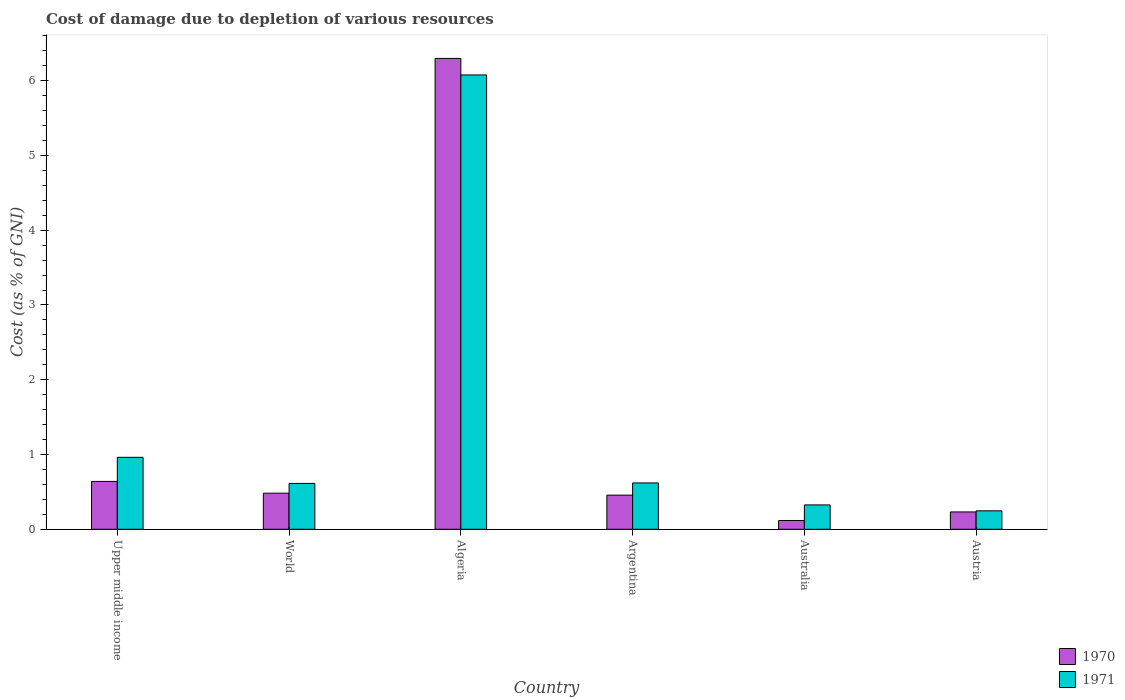How many groups of bars are there?
Your response must be concise. 6. How many bars are there on the 1st tick from the left?
Give a very brief answer. 2. What is the label of the 6th group of bars from the left?
Your answer should be compact. Austria. In how many cases, is the number of bars for a given country not equal to the number of legend labels?
Provide a short and direct response. 0. What is the cost of damage caused due to the depletion of various resources in 1971 in World?
Give a very brief answer. 0.61. Across all countries, what is the maximum cost of damage caused due to the depletion of various resources in 1971?
Make the answer very short. 6.08. Across all countries, what is the minimum cost of damage caused due to the depletion of various resources in 1970?
Provide a short and direct response. 0.12. In which country was the cost of damage caused due to the depletion of various resources in 1970 maximum?
Ensure brevity in your answer.  Algeria. In which country was the cost of damage caused due to the depletion of various resources in 1971 minimum?
Give a very brief answer. Austria. What is the total cost of damage caused due to the depletion of various resources in 1971 in the graph?
Ensure brevity in your answer.  8.85. What is the difference between the cost of damage caused due to the depletion of various resources in 1971 in Australia and that in World?
Give a very brief answer. -0.29. What is the difference between the cost of damage caused due to the depletion of various resources in 1970 in Australia and the cost of damage caused due to the depletion of various resources in 1971 in Austria?
Give a very brief answer. -0.13. What is the average cost of damage caused due to the depletion of various resources in 1971 per country?
Offer a very short reply. 1.47. What is the difference between the cost of damage caused due to the depletion of various resources of/in 1970 and cost of damage caused due to the depletion of various resources of/in 1971 in Argentina?
Your answer should be compact. -0.16. In how many countries, is the cost of damage caused due to the depletion of various resources in 1970 greater than 3.4 %?
Your answer should be compact. 1. What is the ratio of the cost of damage caused due to the depletion of various resources in 1970 in Upper middle income to that in World?
Provide a succinct answer. 1.33. Is the cost of damage caused due to the depletion of various resources in 1971 in Austria less than that in World?
Your response must be concise. Yes. Is the difference between the cost of damage caused due to the depletion of various resources in 1970 in Australia and Austria greater than the difference between the cost of damage caused due to the depletion of various resources in 1971 in Australia and Austria?
Make the answer very short. No. What is the difference between the highest and the second highest cost of damage caused due to the depletion of various resources in 1970?
Provide a short and direct response. 0.16. What is the difference between the highest and the lowest cost of damage caused due to the depletion of various resources in 1970?
Provide a succinct answer. 6.18. In how many countries, is the cost of damage caused due to the depletion of various resources in 1970 greater than the average cost of damage caused due to the depletion of various resources in 1970 taken over all countries?
Keep it short and to the point. 1. Is the sum of the cost of damage caused due to the depletion of various resources in 1970 in Algeria and World greater than the maximum cost of damage caused due to the depletion of various resources in 1971 across all countries?
Your answer should be very brief. Yes. How many bars are there?
Your response must be concise. 12. Are all the bars in the graph horizontal?
Make the answer very short. No. What is the difference between two consecutive major ticks on the Y-axis?
Make the answer very short. 1. Are the values on the major ticks of Y-axis written in scientific E-notation?
Keep it short and to the point. No. Does the graph contain grids?
Make the answer very short. No. Where does the legend appear in the graph?
Make the answer very short. Bottom right. How are the legend labels stacked?
Your answer should be very brief. Vertical. What is the title of the graph?
Offer a terse response. Cost of damage due to depletion of various resources. What is the label or title of the Y-axis?
Provide a short and direct response. Cost (as % of GNI). What is the Cost (as % of GNI) of 1970 in Upper middle income?
Provide a short and direct response. 0.64. What is the Cost (as % of GNI) of 1971 in Upper middle income?
Your answer should be compact. 0.96. What is the Cost (as % of GNI) of 1970 in World?
Your answer should be very brief. 0.48. What is the Cost (as % of GNI) in 1971 in World?
Provide a succinct answer. 0.61. What is the Cost (as % of GNI) of 1970 in Algeria?
Your answer should be compact. 6.3. What is the Cost (as % of GNI) of 1971 in Algeria?
Offer a very short reply. 6.08. What is the Cost (as % of GNI) in 1970 in Argentina?
Ensure brevity in your answer.  0.46. What is the Cost (as % of GNI) of 1971 in Argentina?
Keep it short and to the point. 0.62. What is the Cost (as % of GNI) of 1970 in Australia?
Your answer should be very brief. 0.12. What is the Cost (as % of GNI) of 1971 in Australia?
Provide a succinct answer. 0.33. What is the Cost (as % of GNI) in 1970 in Austria?
Your response must be concise. 0.23. What is the Cost (as % of GNI) in 1971 in Austria?
Make the answer very short. 0.25. Across all countries, what is the maximum Cost (as % of GNI) in 1970?
Provide a succinct answer. 6.3. Across all countries, what is the maximum Cost (as % of GNI) of 1971?
Provide a short and direct response. 6.08. Across all countries, what is the minimum Cost (as % of GNI) of 1970?
Provide a succinct answer. 0.12. Across all countries, what is the minimum Cost (as % of GNI) of 1971?
Provide a succinct answer. 0.25. What is the total Cost (as % of GNI) in 1970 in the graph?
Keep it short and to the point. 8.23. What is the total Cost (as % of GNI) in 1971 in the graph?
Keep it short and to the point. 8.85. What is the difference between the Cost (as % of GNI) in 1970 in Upper middle income and that in World?
Make the answer very short. 0.16. What is the difference between the Cost (as % of GNI) in 1971 in Upper middle income and that in World?
Make the answer very short. 0.35. What is the difference between the Cost (as % of GNI) in 1970 in Upper middle income and that in Algeria?
Give a very brief answer. -5.66. What is the difference between the Cost (as % of GNI) of 1971 in Upper middle income and that in Algeria?
Provide a succinct answer. -5.11. What is the difference between the Cost (as % of GNI) of 1970 in Upper middle income and that in Argentina?
Keep it short and to the point. 0.18. What is the difference between the Cost (as % of GNI) in 1971 in Upper middle income and that in Argentina?
Provide a short and direct response. 0.34. What is the difference between the Cost (as % of GNI) of 1970 in Upper middle income and that in Australia?
Make the answer very short. 0.52. What is the difference between the Cost (as % of GNI) of 1971 in Upper middle income and that in Australia?
Provide a succinct answer. 0.64. What is the difference between the Cost (as % of GNI) in 1970 in Upper middle income and that in Austria?
Offer a very short reply. 0.41. What is the difference between the Cost (as % of GNI) in 1971 in Upper middle income and that in Austria?
Provide a succinct answer. 0.72. What is the difference between the Cost (as % of GNI) in 1970 in World and that in Algeria?
Offer a very short reply. -5.82. What is the difference between the Cost (as % of GNI) in 1971 in World and that in Algeria?
Your answer should be very brief. -5.46. What is the difference between the Cost (as % of GNI) in 1970 in World and that in Argentina?
Your answer should be very brief. 0.03. What is the difference between the Cost (as % of GNI) in 1971 in World and that in Argentina?
Offer a very short reply. -0.01. What is the difference between the Cost (as % of GNI) in 1970 in World and that in Australia?
Offer a terse response. 0.37. What is the difference between the Cost (as % of GNI) in 1971 in World and that in Australia?
Make the answer very short. 0.29. What is the difference between the Cost (as % of GNI) in 1970 in World and that in Austria?
Your answer should be very brief. 0.25. What is the difference between the Cost (as % of GNI) in 1971 in World and that in Austria?
Make the answer very short. 0.37. What is the difference between the Cost (as % of GNI) of 1970 in Algeria and that in Argentina?
Your answer should be very brief. 5.84. What is the difference between the Cost (as % of GNI) of 1971 in Algeria and that in Argentina?
Offer a terse response. 5.46. What is the difference between the Cost (as % of GNI) of 1970 in Algeria and that in Australia?
Your response must be concise. 6.18. What is the difference between the Cost (as % of GNI) of 1971 in Algeria and that in Australia?
Provide a succinct answer. 5.75. What is the difference between the Cost (as % of GNI) of 1970 in Algeria and that in Austria?
Offer a terse response. 6.07. What is the difference between the Cost (as % of GNI) of 1971 in Algeria and that in Austria?
Offer a terse response. 5.83. What is the difference between the Cost (as % of GNI) of 1970 in Argentina and that in Australia?
Ensure brevity in your answer.  0.34. What is the difference between the Cost (as % of GNI) of 1971 in Argentina and that in Australia?
Your response must be concise. 0.29. What is the difference between the Cost (as % of GNI) in 1970 in Argentina and that in Austria?
Your answer should be very brief. 0.22. What is the difference between the Cost (as % of GNI) of 1971 in Argentina and that in Austria?
Keep it short and to the point. 0.37. What is the difference between the Cost (as % of GNI) of 1970 in Australia and that in Austria?
Ensure brevity in your answer.  -0.11. What is the difference between the Cost (as % of GNI) in 1971 in Australia and that in Austria?
Provide a succinct answer. 0.08. What is the difference between the Cost (as % of GNI) of 1970 in Upper middle income and the Cost (as % of GNI) of 1971 in World?
Make the answer very short. 0.03. What is the difference between the Cost (as % of GNI) in 1970 in Upper middle income and the Cost (as % of GNI) in 1971 in Algeria?
Provide a short and direct response. -5.44. What is the difference between the Cost (as % of GNI) in 1970 in Upper middle income and the Cost (as % of GNI) in 1971 in Argentina?
Provide a short and direct response. 0.02. What is the difference between the Cost (as % of GNI) in 1970 in Upper middle income and the Cost (as % of GNI) in 1971 in Australia?
Provide a succinct answer. 0.31. What is the difference between the Cost (as % of GNI) in 1970 in Upper middle income and the Cost (as % of GNI) in 1971 in Austria?
Your response must be concise. 0.39. What is the difference between the Cost (as % of GNI) of 1970 in World and the Cost (as % of GNI) of 1971 in Algeria?
Provide a succinct answer. -5.59. What is the difference between the Cost (as % of GNI) in 1970 in World and the Cost (as % of GNI) in 1971 in Argentina?
Keep it short and to the point. -0.14. What is the difference between the Cost (as % of GNI) in 1970 in World and the Cost (as % of GNI) in 1971 in Australia?
Give a very brief answer. 0.16. What is the difference between the Cost (as % of GNI) of 1970 in World and the Cost (as % of GNI) of 1971 in Austria?
Provide a succinct answer. 0.24. What is the difference between the Cost (as % of GNI) of 1970 in Algeria and the Cost (as % of GNI) of 1971 in Argentina?
Give a very brief answer. 5.68. What is the difference between the Cost (as % of GNI) of 1970 in Algeria and the Cost (as % of GNI) of 1971 in Australia?
Provide a succinct answer. 5.97. What is the difference between the Cost (as % of GNI) in 1970 in Algeria and the Cost (as % of GNI) in 1971 in Austria?
Give a very brief answer. 6.05. What is the difference between the Cost (as % of GNI) in 1970 in Argentina and the Cost (as % of GNI) in 1971 in Australia?
Offer a terse response. 0.13. What is the difference between the Cost (as % of GNI) in 1970 in Argentina and the Cost (as % of GNI) in 1971 in Austria?
Ensure brevity in your answer.  0.21. What is the difference between the Cost (as % of GNI) of 1970 in Australia and the Cost (as % of GNI) of 1971 in Austria?
Offer a terse response. -0.13. What is the average Cost (as % of GNI) in 1970 per country?
Ensure brevity in your answer.  1.37. What is the average Cost (as % of GNI) of 1971 per country?
Give a very brief answer. 1.47. What is the difference between the Cost (as % of GNI) in 1970 and Cost (as % of GNI) in 1971 in Upper middle income?
Offer a terse response. -0.32. What is the difference between the Cost (as % of GNI) in 1970 and Cost (as % of GNI) in 1971 in World?
Your response must be concise. -0.13. What is the difference between the Cost (as % of GNI) of 1970 and Cost (as % of GNI) of 1971 in Algeria?
Offer a very short reply. 0.22. What is the difference between the Cost (as % of GNI) in 1970 and Cost (as % of GNI) in 1971 in Argentina?
Your answer should be compact. -0.16. What is the difference between the Cost (as % of GNI) in 1970 and Cost (as % of GNI) in 1971 in Australia?
Your response must be concise. -0.21. What is the difference between the Cost (as % of GNI) in 1970 and Cost (as % of GNI) in 1971 in Austria?
Make the answer very short. -0.01. What is the ratio of the Cost (as % of GNI) of 1970 in Upper middle income to that in World?
Your response must be concise. 1.33. What is the ratio of the Cost (as % of GNI) of 1971 in Upper middle income to that in World?
Your answer should be compact. 1.57. What is the ratio of the Cost (as % of GNI) in 1970 in Upper middle income to that in Algeria?
Offer a terse response. 0.1. What is the ratio of the Cost (as % of GNI) in 1971 in Upper middle income to that in Algeria?
Keep it short and to the point. 0.16. What is the ratio of the Cost (as % of GNI) of 1970 in Upper middle income to that in Argentina?
Make the answer very short. 1.4. What is the ratio of the Cost (as % of GNI) in 1971 in Upper middle income to that in Argentina?
Ensure brevity in your answer.  1.55. What is the ratio of the Cost (as % of GNI) of 1970 in Upper middle income to that in Australia?
Offer a terse response. 5.45. What is the ratio of the Cost (as % of GNI) of 1971 in Upper middle income to that in Australia?
Offer a terse response. 2.95. What is the ratio of the Cost (as % of GNI) of 1970 in Upper middle income to that in Austria?
Your response must be concise. 2.76. What is the ratio of the Cost (as % of GNI) in 1971 in Upper middle income to that in Austria?
Your response must be concise. 3.9. What is the ratio of the Cost (as % of GNI) in 1970 in World to that in Algeria?
Provide a short and direct response. 0.08. What is the ratio of the Cost (as % of GNI) in 1971 in World to that in Algeria?
Make the answer very short. 0.1. What is the ratio of the Cost (as % of GNI) in 1970 in World to that in Argentina?
Your response must be concise. 1.06. What is the ratio of the Cost (as % of GNI) in 1971 in World to that in Argentina?
Give a very brief answer. 0.99. What is the ratio of the Cost (as % of GNI) of 1970 in World to that in Australia?
Make the answer very short. 4.11. What is the ratio of the Cost (as % of GNI) of 1971 in World to that in Australia?
Provide a short and direct response. 1.88. What is the ratio of the Cost (as % of GNI) in 1970 in World to that in Austria?
Make the answer very short. 2.08. What is the ratio of the Cost (as % of GNI) in 1971 in World to that in Austria?
Your response must be concise. 2.48. What is the ratio of the Cost (as % of GNI) of 1970 in Algeria to that in Argentina?
Ensure brevity in your answer.  13.8. What is the ratio of the Cost (as % of GNI) in 1971 in Algeria to that in Argentina?
Offer a terse response. 9.81. What is the ratio of the Cost (as % of GNI) of 1970 in Algeria to that in Australia?
Your response must be concise. 53.61. What is the ratio of the Cost (as % of GNI) in 1971 in Algeria to that in Australia?
Provide a succinct answer. 18.65. What is the ratio of the Cost (as % of GNI) of 1970 in Algeria to that in Austria?
Offer a terse response. 27.15. What is the ratio of the Cost (as % of GNI) in 1971 in Algeria to that in Austria?
Keep it short and to the point. 24.61. What is the ratio of the Cost (as % of GNI) of 1970 in Argentina to that in Australia?
Your response must be concise. 3.89. What is the ratio of the Cost (as % of GNI) of 1971 in Argentina to that in Australia?
Keep it short and to the point. 1.9. What is the ratio of the Cost (as % of GNI) of 1970 in Argentina to that in Austria?
Provide a succinct answer. 1.97. What is the ratio of the Cost (as % of GNI) in 1971 in Argentina to that in Austria?
Keep it short and to the point. 2.51. What is the ratio of the Cost (as % of GNI) in 1970 in Australia to that in Austria?
Your answer should be compact. 0.51. What is the ratio of the Cost (as % of GNI) of 1971 in Australia to that in Austria?
Make the answer very short. 1.32. What is the difference between the highest and the second highest Cost (as % of GNI) of 1970?
Your answer should be compact. 5.66. What is the difference between the highest and the second highest Cost (as % of GNI) of 1971?
Your response must be concise. 5.11. What is the difference between the highest and the lowest Cost (as % of GNI) in 1970?
Make the answer very short. 6.18. What is the difference between the highest and the lowest Cost (as % of GNI) of 1971?
Offer a very short reply. 5.83. 